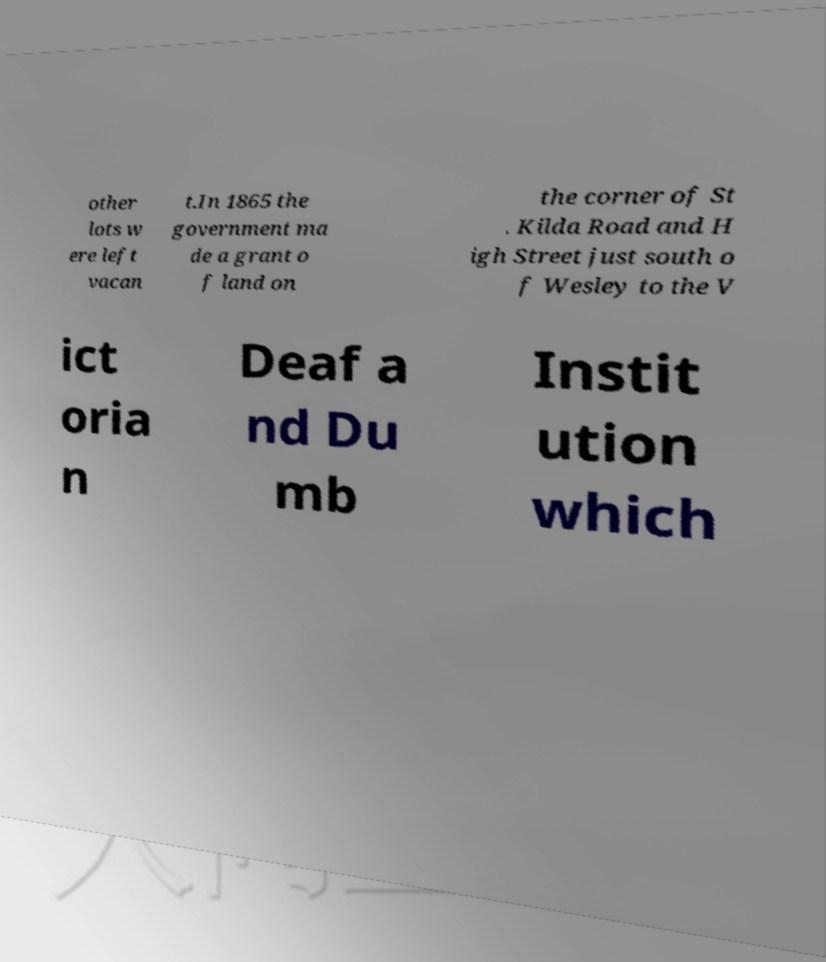There's text embedded in this image that I need extracted. Can you transcribe it verbatim? other lots w ere left vacan t.In 1865 the government ma de a grant o f land on the corner of St . Kilda Road and H igh Street just south o f Wesley to the V ict oria n Deaf a nd Du mb Instit ution which 